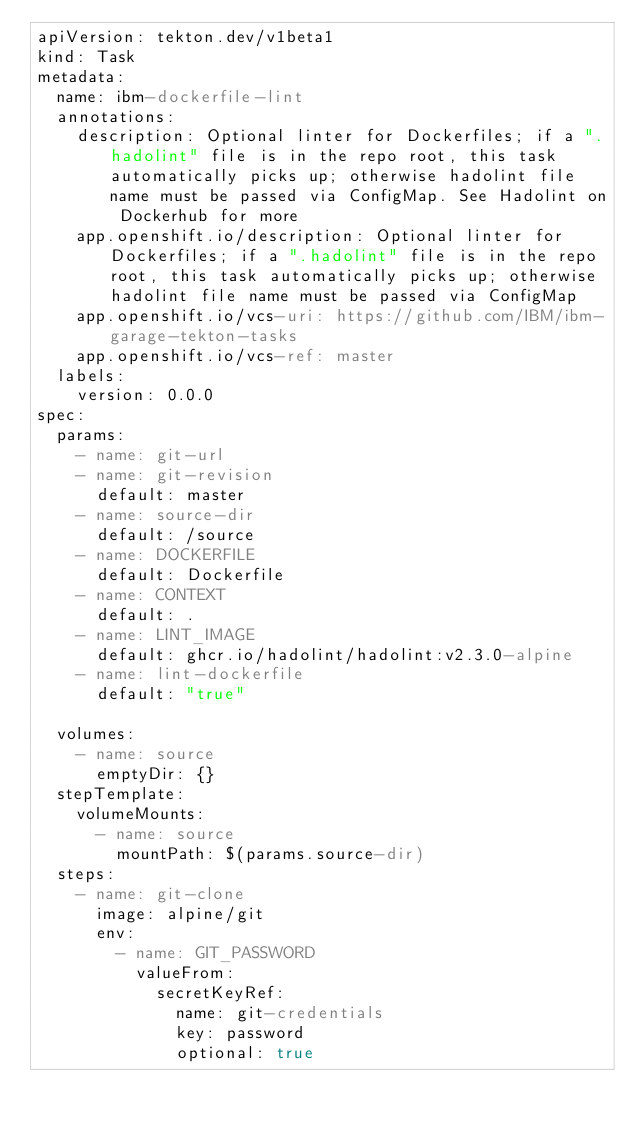Convert code to text. <code><loc_0><loc_0><loc_500><loc_500><_YAML_>apiVersion: tekton.dev/v1beta1
kind: Task
metadata:
  name: ibm-dockerfile-lint
  annotations:
    description: Optional linter for Dockerfiles; if a ".hadolint" file is in the repo root, this task automatically picks up; otherwise hadolint file name must be passed via ConfigMap. See Hadolint on Dockerhub for more
    app.openshift.io/description: Optional linter for Dockerfiles; if a ".hadolint" file is in the repo root, this task automatically picks up; otherwise hadolint file name must be passed via ConfigMap
    app.openshift.io/vcs-uri: https://github.com/IBM/ibm-garage-tekton-tasks
    app.openshift.io/vcs-ref: master
  labels:
    version: 0.0.0
spec:
  params:
    - name: git-url
    - name: git-revision
      default: master
    - name: source-dir
      default: /source
    - name: DOCKERFILE
      default: Dockerfile
    - name: CONTEXT
      default: .
    - name: LINT_IMAGE
      default: ghcr.io/hadolint/hadolint:v2.3.0-alpine
    - name: lint-dockerfile
      default: "true"

  volumes:
    - name: source
      emptyDir: {}
  stepTemplate:
    volumeMounts:
      - name: source
        mountPath: $(params.source-dir)
  steps:
    - name: git-clone
      image: alpine/git
      env:
        - name: GIT_PASSWORD
          valueFrom:
            secretKeyRef:
              name: git-credentials
              key: password
              optional: true</code> 